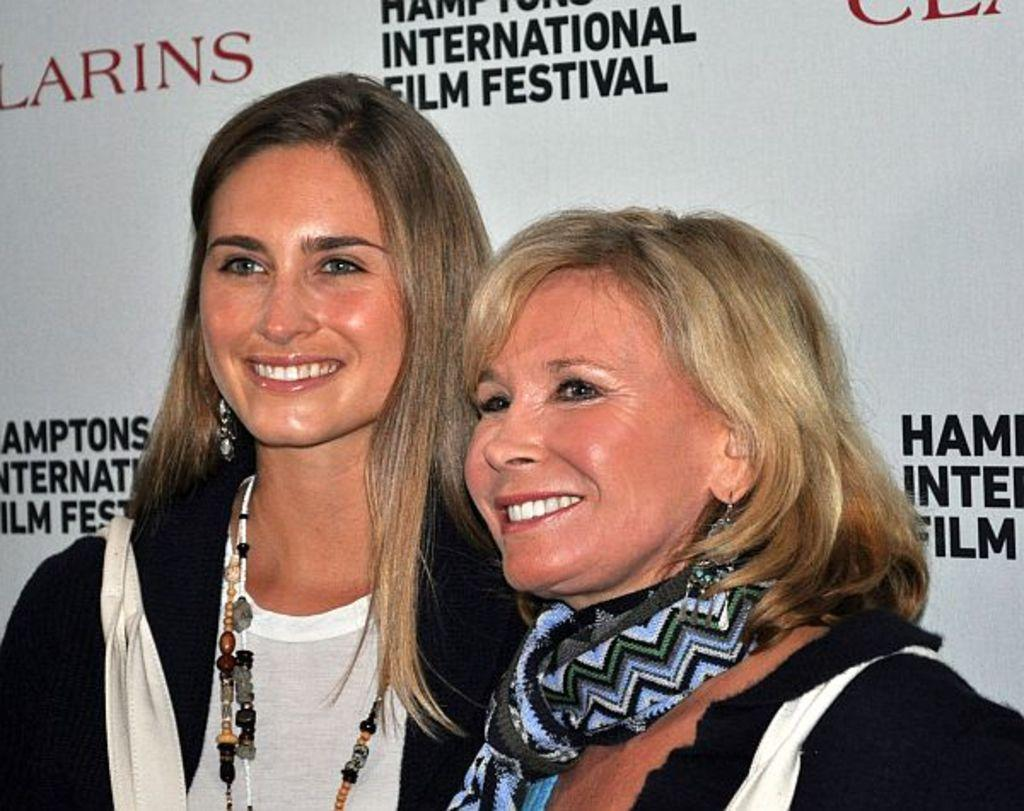How many people are in the image? There are two women in the image. What is the facial expression of the women? The women are smiling. What can be seen in the background of the image? There is a banner with text on it in the background. What type of railway is visible in the image? There is no railway present in the image. How many chickens can be seen on top of the banner? There are no chickens present in the image, and the banner is not elevated or on top of anything. 